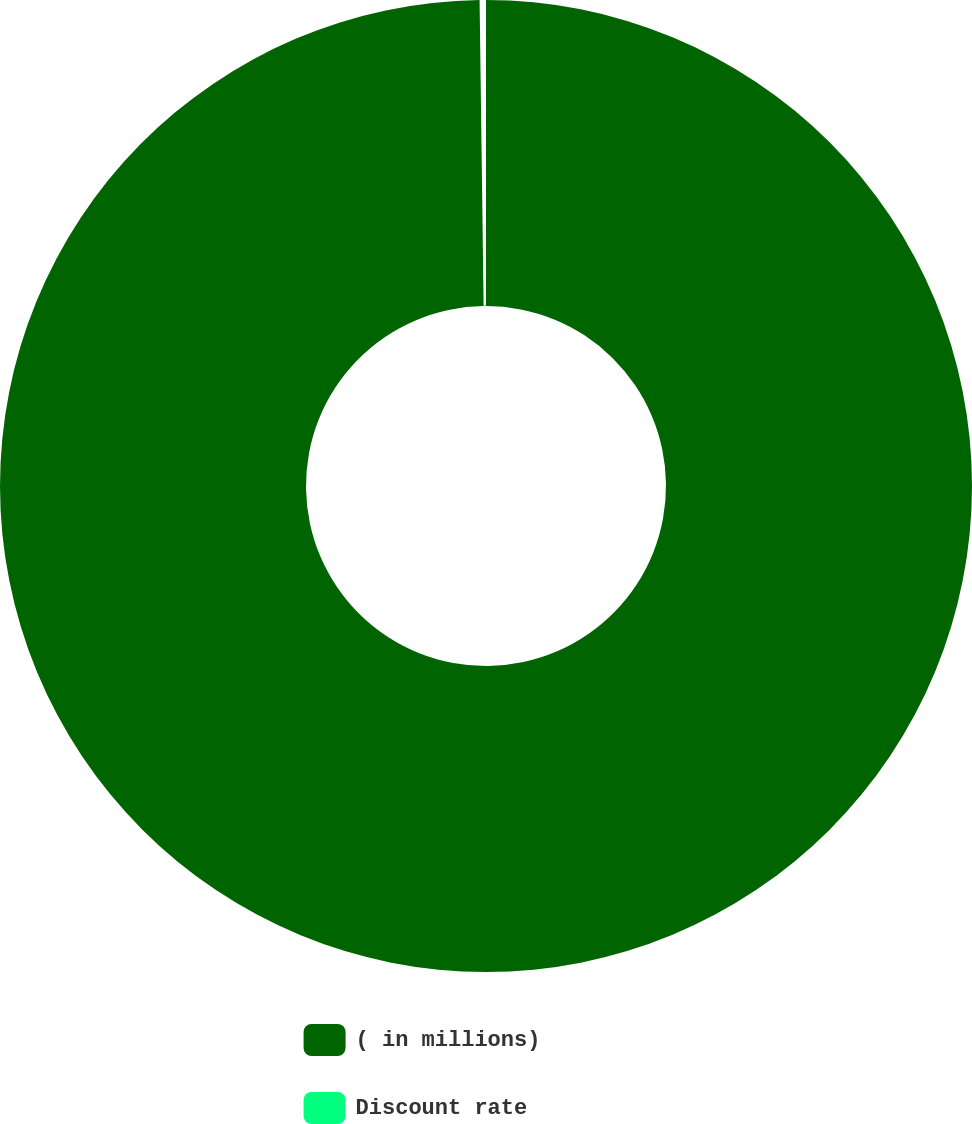Convert chart to OTSL. <chart><loc_0><loc_0><loc_500><loc_500><pie_chart><fcel>( in millions)<fcel>Discount rate<nl><fcel>99.79%<fcel>0.21%<nl></chart> 